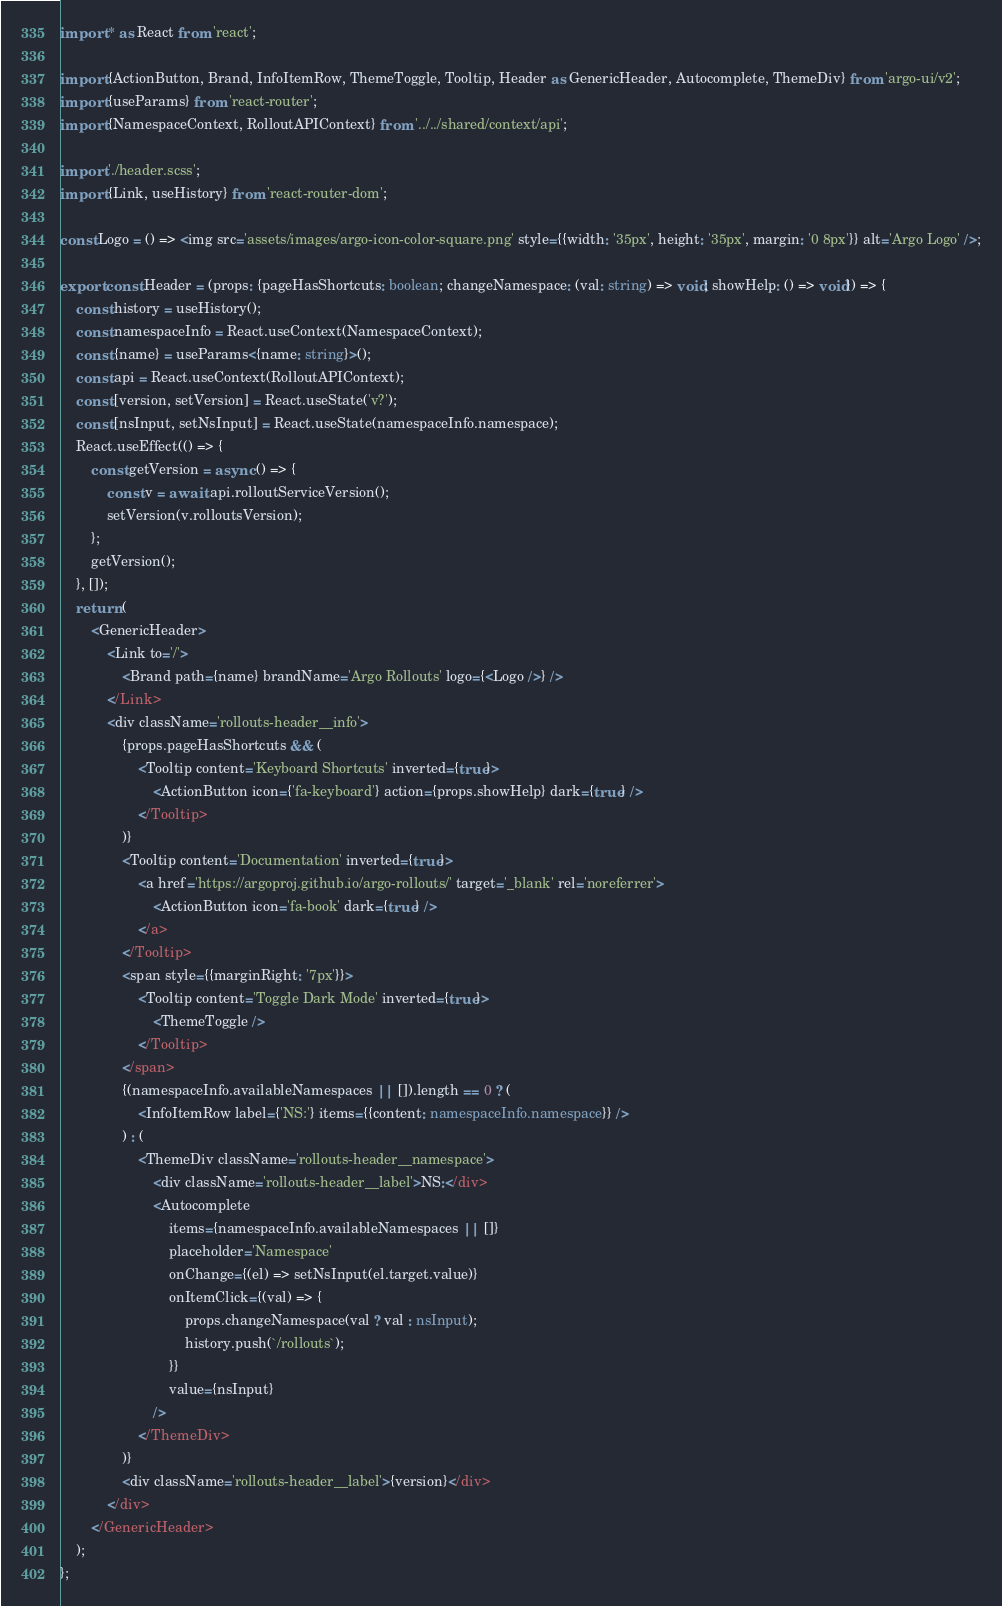Convert code to text. <code><loc_0><loc_0><loc_500><loc_500><_TypeScript_>import * as React from 'react';

import {ActionButton, Brand, InfoItemRow, ThemeToggle, Tooltip, Header as GenericHeader, Autocomplete, ThemeDiv} from 'argo-ui/v2';
import {useParams} from 'react-router';
import {NamespaceContext, RolloutAPIContext} from '../../shared/context/api';

import './header.scss';
import {Link, useHistory} from 'react-router-dom';

const Logo = () => <img src='assets/images/argo-icon-color-square.png' style={{width: '35px', height: '35px', margin: '0 8px'}} alt='Argo Logo' />;

export const Header = (props: {pageHasShortcuts: boolean; changeNamespace: (val: string) => void; showHelp: () => void}) => {
    const history = useHistory();
    const namespaceInfo = React.useContext(NamespaceContext);
    const {name} = useParams<{name: string}>();
    const api = React.useContext(RolloutAPIContext);
    const [version, setVersion] = React.useState('v?');
    const [nsInput, setNsInput] = React.useState(namespaceInfo.namespace);
    React.useEffect(() => {
        const getVersion = async () => {
            const v = await api.rolloutServiceVersion();
            setVersion(v.rolloutsVersion);
        };
        getVersion();
    }, []);
    return (
        <GenericHeader>
            <Link to='/'>
                <Brand path={name} brandName='Argo Rollouts' logo={<Logo />} />
            </Link>
            <div className='rollouts-header__info'>
                {props.pageHasShortcuts && (
                    <Tooltip content='Keyboard Shortcuts' inverted={true}>
                        <ActionButton icon={'fa-keyboard'} action={props.showHelp} dark={true} />
                    </Tooltip>
                )}
                <Tooltip content='Documentation' inverted={true}>
                    <a href='https://argoproj.github.io/argo-rollouts/' target='_blank' rel='noreferrer'>
                        <ActionButton icon='fa-book' dark={true} />
                    </a>
                </Tooltip>
                <span style={{marginRight: '7px'}}>
                    <Tooltip content='Toggle Dark Mode' inverted={true}>
                        <ThemeToggle />
                    </Tooltip>
                </span>
                {(namespaceInfo.availableNamespaces || []).length == 0 ? (
                    <InfoItemRow label={'NS:'} items={{content: namespaceInfo.namespace}} />
                ) : (
                    <ThemeDiv className='rollouts-header__namespace'>
                        <div className='rollouts-header__label'>NS:</div>
                        <Autocomplete
                            items={namespaceInfo.availableNamespaces || []}
                            placeholder='Namespace'
                            onChange={(el) => setNsInput(el.target.value)}
                            onItemClick={(val) => {
                                props.changeNamespace(val ? val : nsInput);
                                history.push(`/rollouts`);
                            }}
                            value={nsInput}
                        />
                    </ThemeDiv>
                )}
                <div className='rollouts-header__label'>{version}</div>
            </div>
        </GenericHeader>
    );
};
</code> 